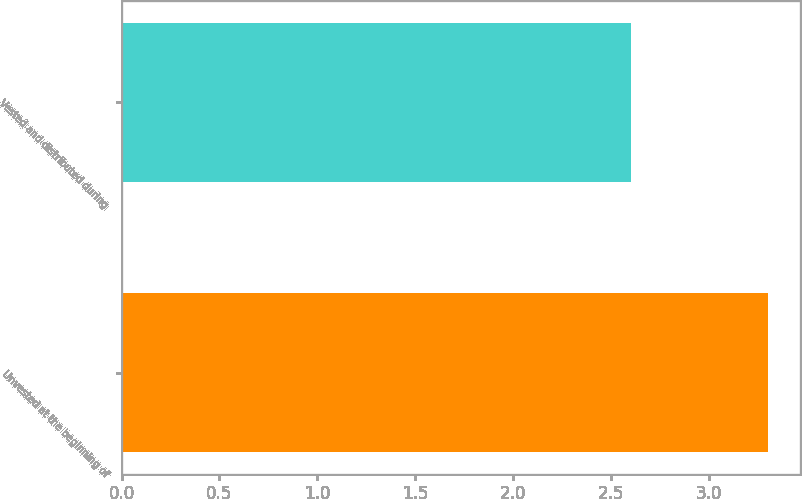Convert chart. <chart><loc_0><loc_0><loc_500><loc_500><bar_chart><fcel>Unvested at the beginning of<fcel>Vested and distributed during<nl><fcel>3.3<fcel>2.6<nl></chart> 